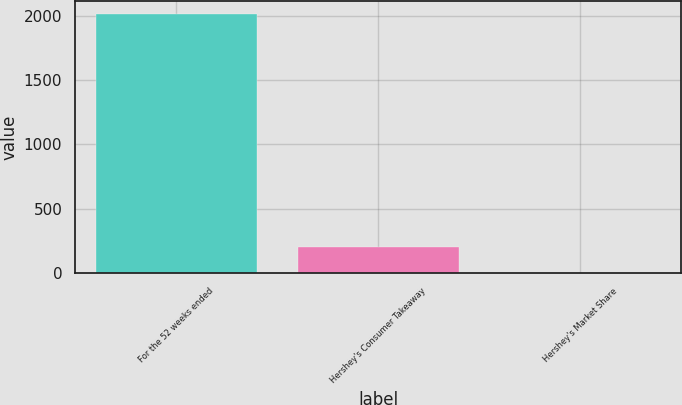Convert chart to OTSL. <chart><loc_0><loc_0><loc_500><loc_500><bar_chart><fcel>For the 52 weeks ended<fcel>Hershey's Consumer Takeaway<fcel>Hershey's Market Share<nl><fcel>2014<fcel>201.67<fcel>0.3<nl></chart> 